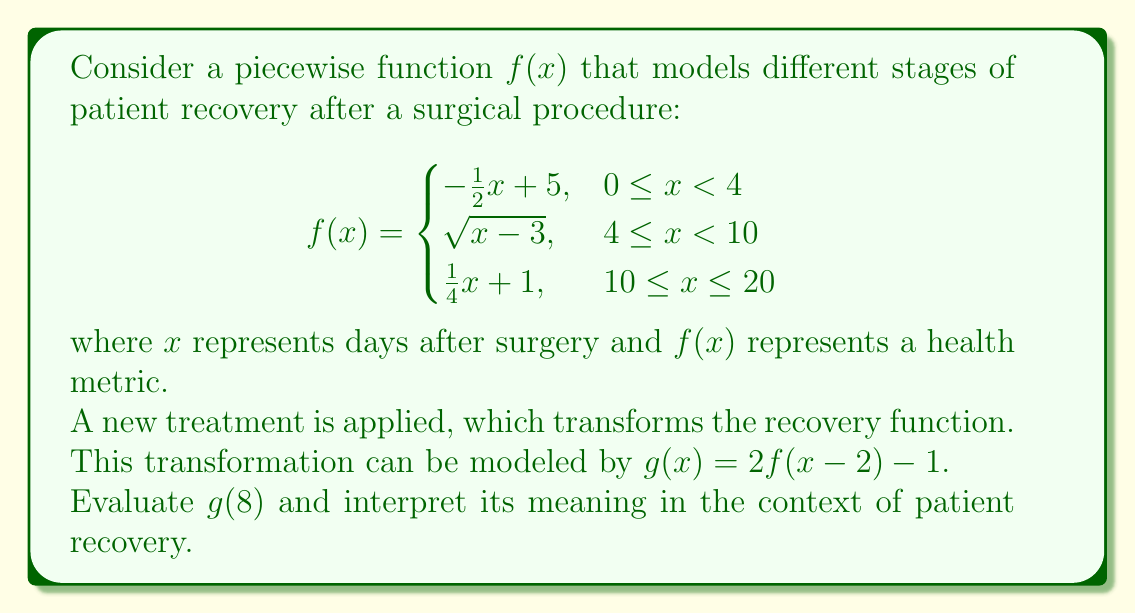Give your solution to this math problem. To solve this problem, we'll follow these steps:

1) First, we need to find $f(8-2) = f(6)$, as the transformation shifts the function 2 units to the right.

2) To find $f(6)$, we need to determine which piece of the piecewise function to use:
   $6$ is in the interval $[4, 10)$, so we use the second piece: $\sqrt{x-3}$

3) Calculate $f(6)$:
   $f(6) = \sqrt{6-3} = \sqrt{3}$

4) Now apply the transformation $g(x) = 2f(x-2) - 1$:
   $g(8) = 2f(8-2) - 1 = 2f(6) - 1 = 2\sqrt{3} - 1$

5) Simplify:
   $2\sqrt{3} - 1 \approx 2.46$

Interpretation: The value $g(8) \approx 2.46$ represents the health metric 8 days after surgery with the new treatment. Compared to the original function $f(x)$, this value is higher (as $g(x)$ doubles the output of $f(x)$ and subtracts 1), indicating that the new treatment may lead to faster recovery or improved health metrics at this stage of recovery.
Answer: $g(8) = 2\sqrt{3} - 1 \approx 2.46$ 